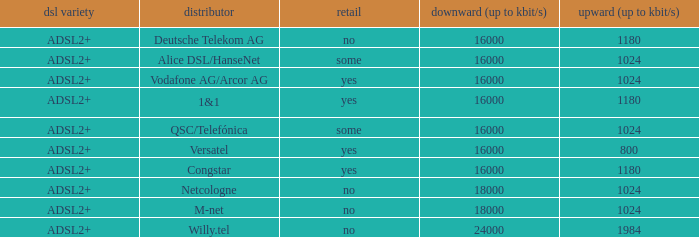How many providers are there where the resale category is yes and bandwith is up is 1024? 1.0. 